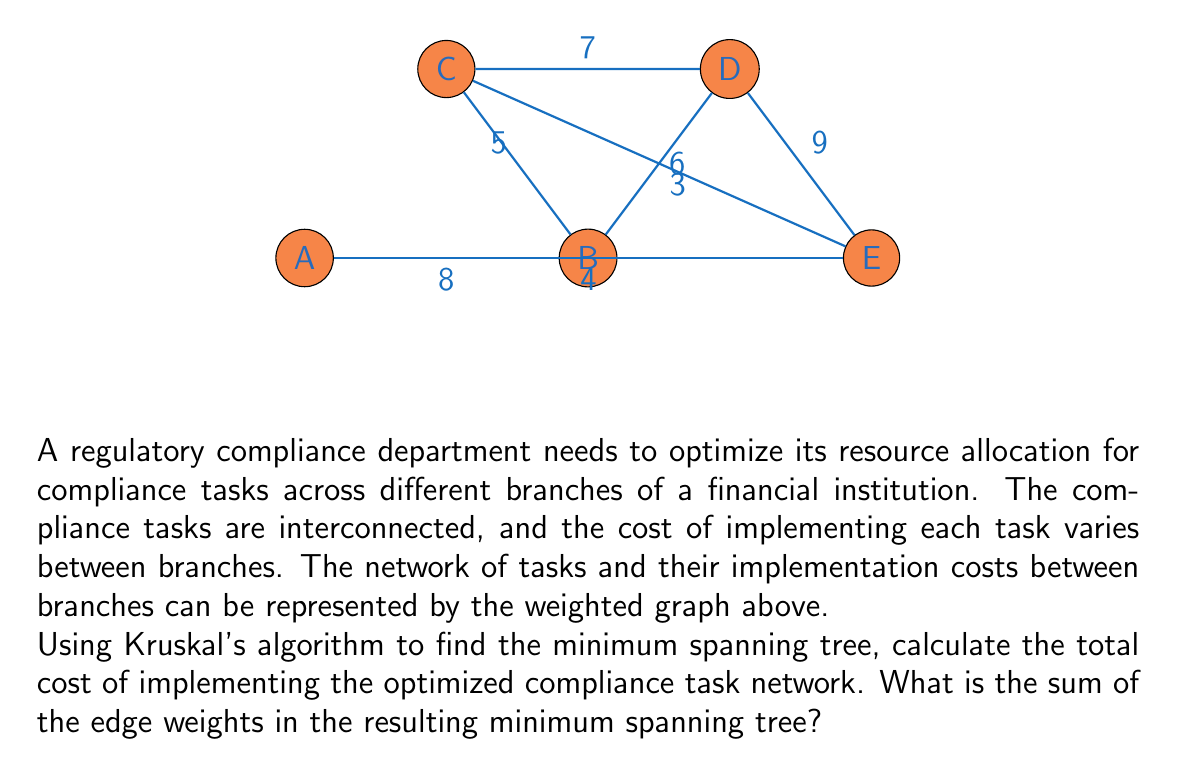What is the answer to this math problem? To solve this problem using Kruskal's algorithm for finding the minimum spanning tree (MST), we'll follow these steps:

1) First, sort all edges by weight in ascending order:
   CE: 3
   EA: 4
   BC: 5
   BD: 6
   CD: 7
   AB: 8
   DE: 9

2) Start with an empty set of edges and add edges one by one, ensuring no cycles are formed:

   a) Add CE (3) - connects C and E
   b) Add EA (4) - connects E and A
   c) Add BC (5) - connects B to the existing tree
   d) Add CD (7) - connects D to the existing tree

3) At this point, we have added 4 edges, which is sufficient for a minimum spanning tree in a graph with 5 vertices (n-1 edges where n is the number of vertices).

4) The minimum spanning tree consists of edges: CE, EA, BC, and CD.

5) Calculate the sum of the weights of these edges:
   $$ 3 + 4 + 5 + 7 = 19 $$

Therefore, the total cost of implementing the optimized compliance task network is 19.
Answer: 19 